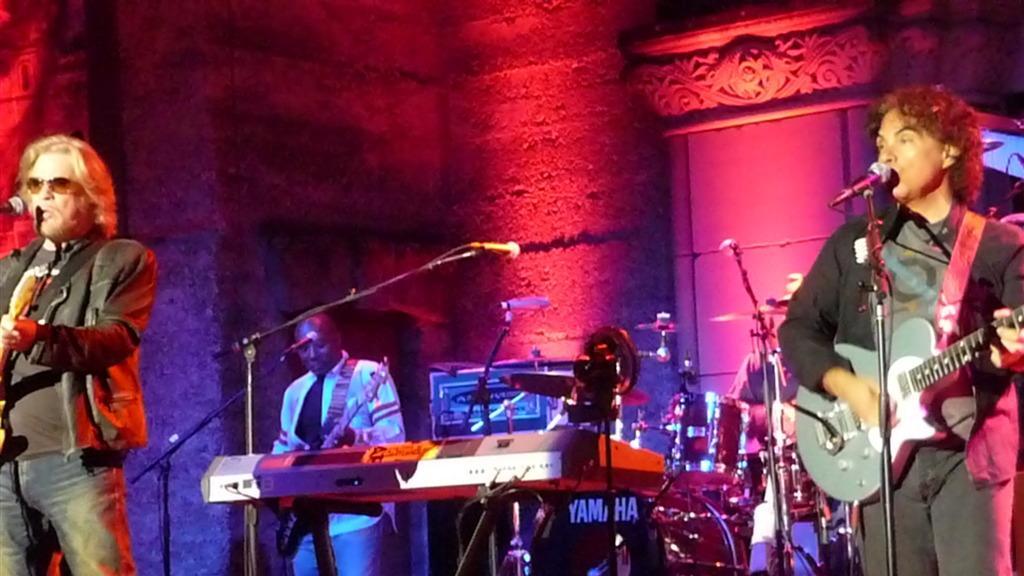Please provide a concise description of this image. In this image a man wearing black colour jacket and also wearing a spectacles holding a guitar and back of him a person standing and playing guitar,in front of him there is a mike on the middle there are some musical instruments. On the right side the man wearing black colour shirt and holding a guitar. On the back of him the man standing and playing musical instrument and there is wall with light and there is a gate. 